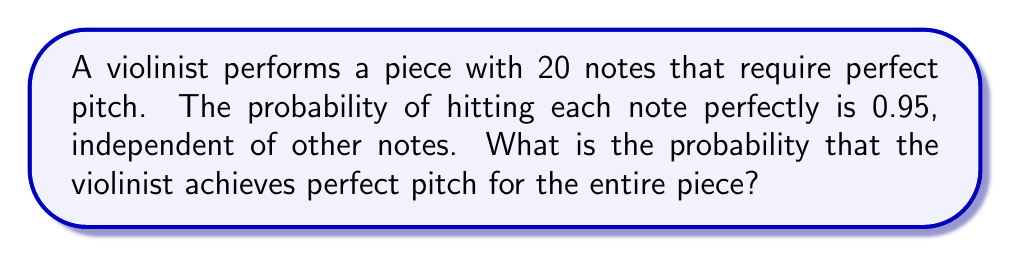Give your solution to this math problem. To solve this problem, we need to use the concept of independent events in probability theory.

1. Each note is an independent event with a probability of 0.95 of being played perfectly.

2. To achieve perfect pitch for the entire piece, all 20 notes must be played perfectly.

3. The probability of all independent events occurring is the product of their individual probabilities.

4. Let $P(\text{perfect})$ be the probability of achieving perfect pitch for the entire piece.

5. We can calculate this as:

   $$P(\text{perfect}) = 0.95^{20}$$

6. Using a calculator or computer:

   $$P(\text{perfect}) \approx 0.3585$$

7. Convert to a percentage:

   $$P(\text{perfect}) \approx 35.85\%$$

Therefore, the probability of the violinist achieving perfect pitch for the entire piece is approximately 35.85%.
Answer: $0.95^{20} \approx 35.85\%$ 